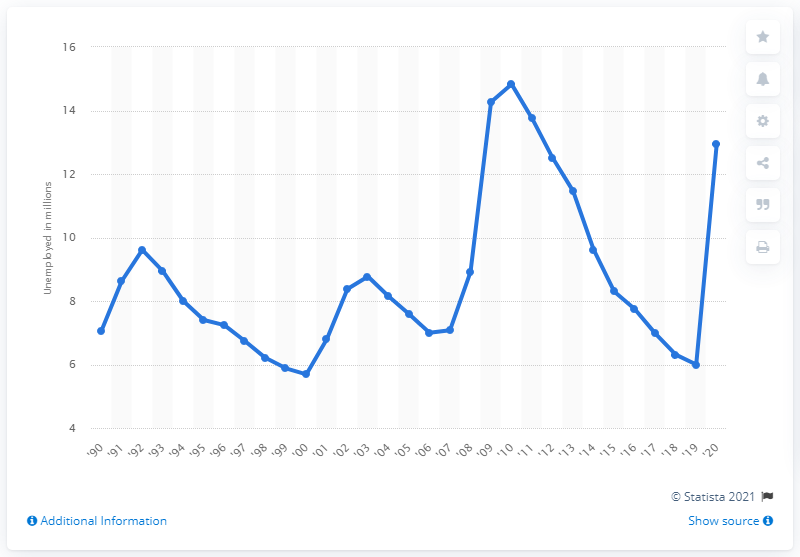List a handful of essential elements in this visual. In 2020, the average number of individuals seeking employment was 12.95. 